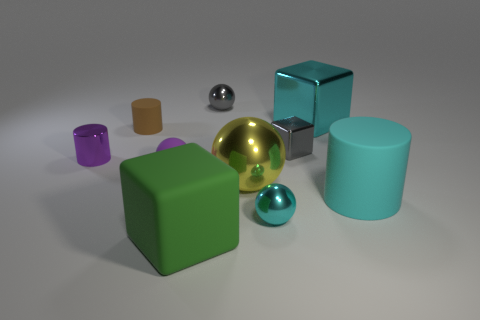There is a yellow sphere that is the same material as the tiny cyan ball; what is its size? The yellow sphere appears significantly larger than the tiny cyan ball. While the exact dimensions cannot be provided without measurement tools, by visual estimation, the yellow sphere is approximately twice the diameter of the cyan ball. 